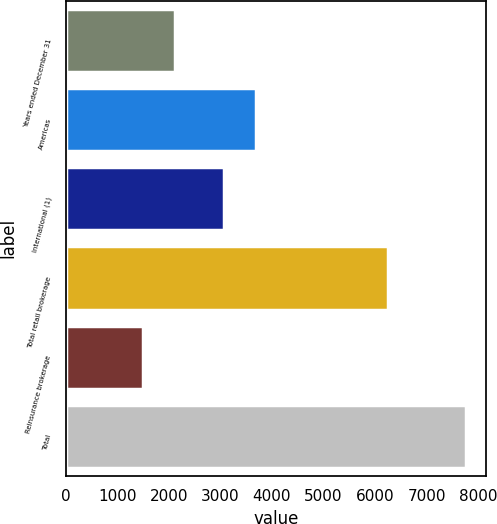Convert chart. <chart><loc_0><loc_0><loc_500><loc_500><bar_chart><fcel>Years ended December 31<fcel>Americas<fcel>International (1)<fcel>Total retail brokerage<fcel>Reinsurance brokerage<fcel>Total<nl><fcel>2130.6<fcel>3690.6<fcel>3065<fcel>6256<fcel>1505<fcel>7761<nl></chart> 